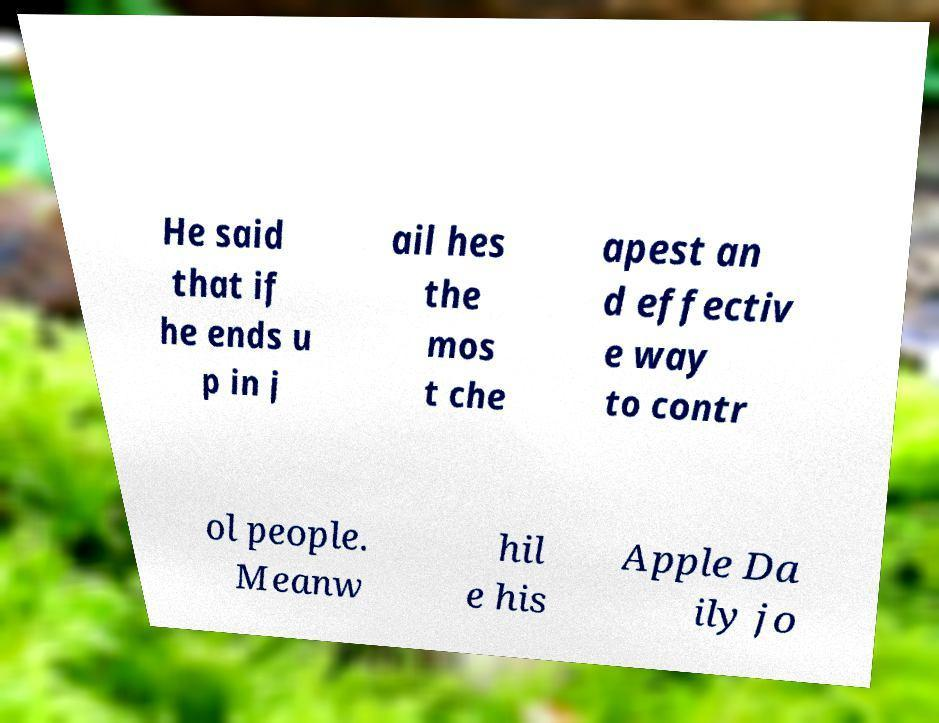Could you extract and type out the text from this image? He said that if he ends u p in j ail hes the mos t che apest an d effectiv e way to contr ol people. Meanw hil e his Apple Da ily jo 